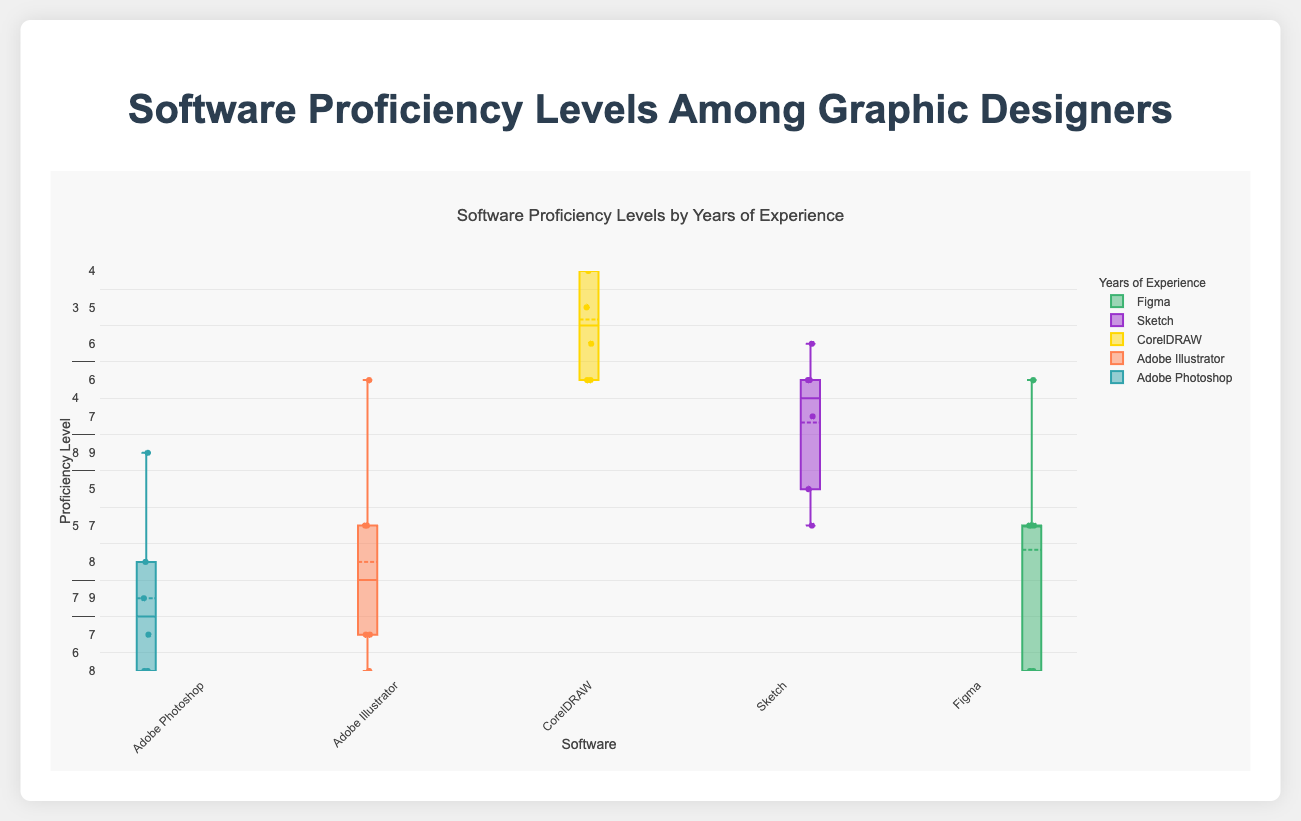what is the title of the figure? The title is usually located at the top center of the plot. In this case, the title is displayed prominently.
Answer: Software Proficiency Levels by Years of Experience What does the y-axis represent? The y-axis typically has a title indicating what it measures. In this case, the y-axis is labeled "Proficiency Level," indicating that it measures the proficiency levels of graphic designers.
Answer: Proficiency Level What do the colors in the plot represent? Each box plot is represented by a different color, which corresponds to different software. The legend in the plot matches the colors to software names.
Answer: Different software (Adobe Photoshop, Adobe Illustrator, CorelDRAW, Sketch, Figma) Which software has the highest median proficiency level for the "1-3 years" experience group? The median is indicated by the line inside the box. For the "1-3 years" experience group, the highest median proficiency level is observed for Adobe Photoshop.
Answer: Adobe Photoshop How does the proficiency in Adobe Illustrator change with increasing years of experience? By observing the box plots from left to right, we see that the median increases as the years of experience increase.
Answer: It increases What is the range of proficiency levels for Figma in the "7-10 years" experience group? The range is determined by the minimum and maximum values indicated by the bottom and top whiskers of the box plot. For "7-10 years," the values range from 7 to 9.
Answer: 7 to 9 For which software does the proficiency level show the least variation among the "10+ years" experience group? Variation is indicated by the height of the box (interquartile range). For "10+ years," Adobe Photoshop and Adobe Illustrator show lesser variation compared to others but Adobe Photoshop has the smallest box.
Answer: Adobe Photoshop Compare the median proficiency of CorelDRAW between "1-3 years" and "10+ years" experience groups. The median for "1-3 years" is around 3, while for "10+ years" it is around 7. This information can be observed from the central line in each box plot.
Answer: It increases from 3 to 7 Which software shows a significant jump in proficiency level from "1-3 years" to "4-6 years"? By comparing the median lines of each software for these two experience groups, Adobe Photoshop has the most noticeable increase in proficiency level.
Answer: Adobe Photoshop For Sketch, which experience group has the highest median proficiency level? By observing the line inside the boxes across the experience groups, the highest median is found for the "10+ years" experience group.
Answer: 10+ years 